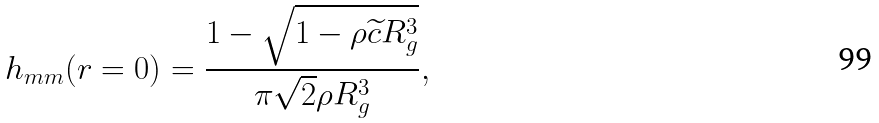<formula> <loc_0><loc_0><loc_500><loc_500>h _ { m m } ( r = 0 ) = \frac { 1 - \sqrt { 1 - \rho \widetilde { c } R _ { g } ^ { 3 } } } { \pi \sqrt { 2 } \rho R _ { g } ^ { 3 } } ,</formula> 